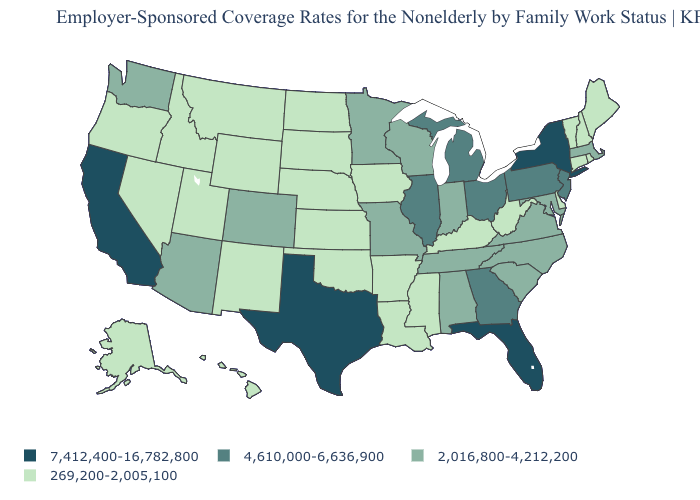What is the value of Mississippi?
Write a very short answer. 269,200-2,005,100. Name the states that have a value in the range 269,200-2,005,100?
Write a very short answer. Alaska, Arkansas, Connecticut, Delaware, Hawaii, Idaho, Iowa, Kansas, Kentucky, Louisiana, Maine, Mississippi, Montana, Nebraska, Nevada, New Hampshire, New Mexico, North Dakota, Oklahoma, Oregon, Rhode Island, South Dakota, Utah, Vermont, West Virginia, Wyoming. How many symbols are there in the legend?
Write a very short answer. 4. Which states have the highest value in the USA?
Short answer required. California, Florida, New York, Texas. Does Kentucky have the lowest value in the USA?
Short answer required. Yes. Name the states that have a value in the range 7,412,400-16,782,800?
Give a very brief answer. California, Florida, New York, Texas. Name the states that have a value in the range 4,610,000-6,636,900?
Short answer required. Georgia, Illinois, Michigan, New Jersey, Ohio, Pennsylvania. Does New York have the highest value in the USA?
Write a very short answer. Yes. Among the states that border Virginia , does Maryland have the lowest value?
Keep it brief. No. Name the states that have a value in the range 269,200-2,005,100?
Short answer required. Alaska, Arkansas, Connecticut, Delaware, Hawaii, Idaho, Iowa, Kansas, Kentucky, Louisiana, Maine, Mississippi, Montana, Nebraska, Nevada, New Hampshire, New Mexico, North Dakota, Oklahoma, Oregon, Rhode Island, South Dakota, Utah, Vermont, West Virginia, Wyoming. Does the first symbol in the legend represent the smallest category?
Be succinct. No. Does South Dakota have the lowest value in the MidWest?
Keep it brief. Yes. Does the map have missing data?
Be succinct. No. What is the highest value in the USA?
Give a very brief answer. 7,412,400-16,782,800. What is the lowest value in the MidWest?
Write a very short answer. 269,200-2,005,100. 